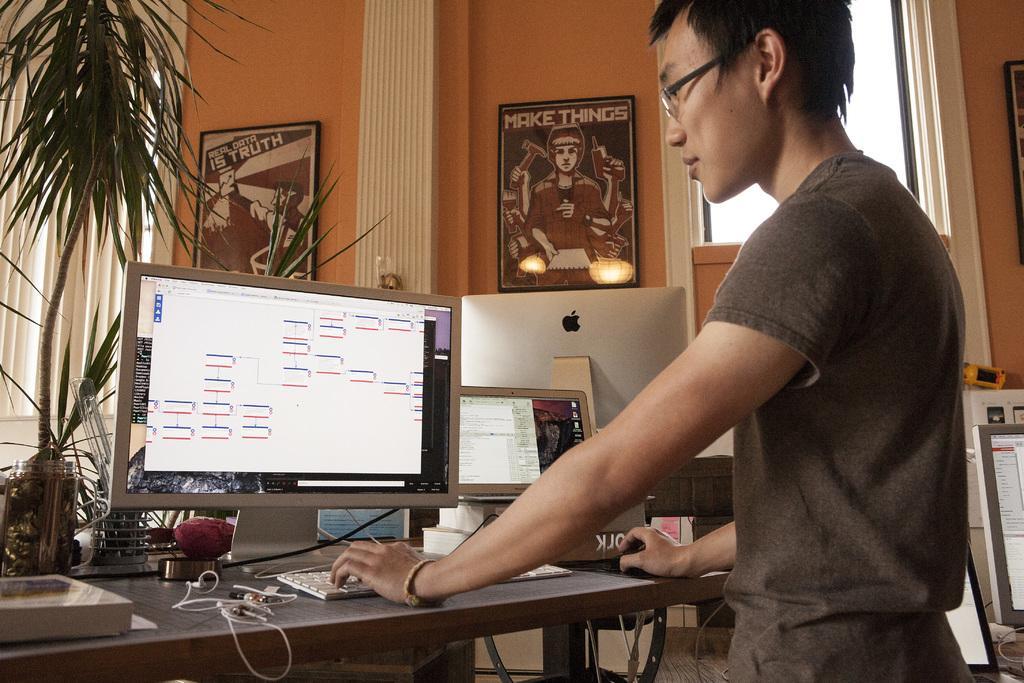Can you describe this image briefly? As we can see in the image there is a wall, plant, man standing over here and a table. On table there are laptops, keyboard and a book. 